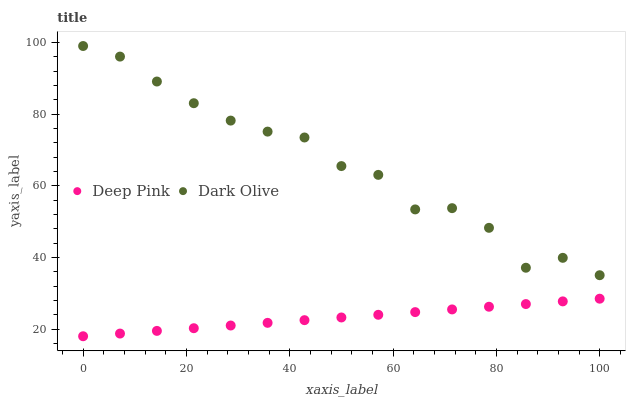Does Deep Pink have the minimum area under the curve?
Answer yes or no. Yes. Does Dark Olive have the maximum area under the curve?
Answer yes or no. Yes. Does Deep Pink have the maximum area under the curve?
Answer yes or no. No. Is Deep Pink the smoothest?
Answer yes or no. Yes. Is Dark Olive the roughest?
Answer yes or no. Yes. Is Deep Pink the roughest?
Answer yes or no. No. Does Deep Pink have the lowest value?
Answer yes or no. Yes. Does Dark Olive have the highest value?
Answer yes or no. Yes. Does Deep Pink have the highest value?
Answer yes or no. No. Is Deep Pink less than Dark Olive?
Answer yes or no. Yes. Is Dark Olive greater than Deep Pink?
Answer yes or no. Yes. Does Deep Pink intersect Dark Olive?
Answer yes or no. No. 